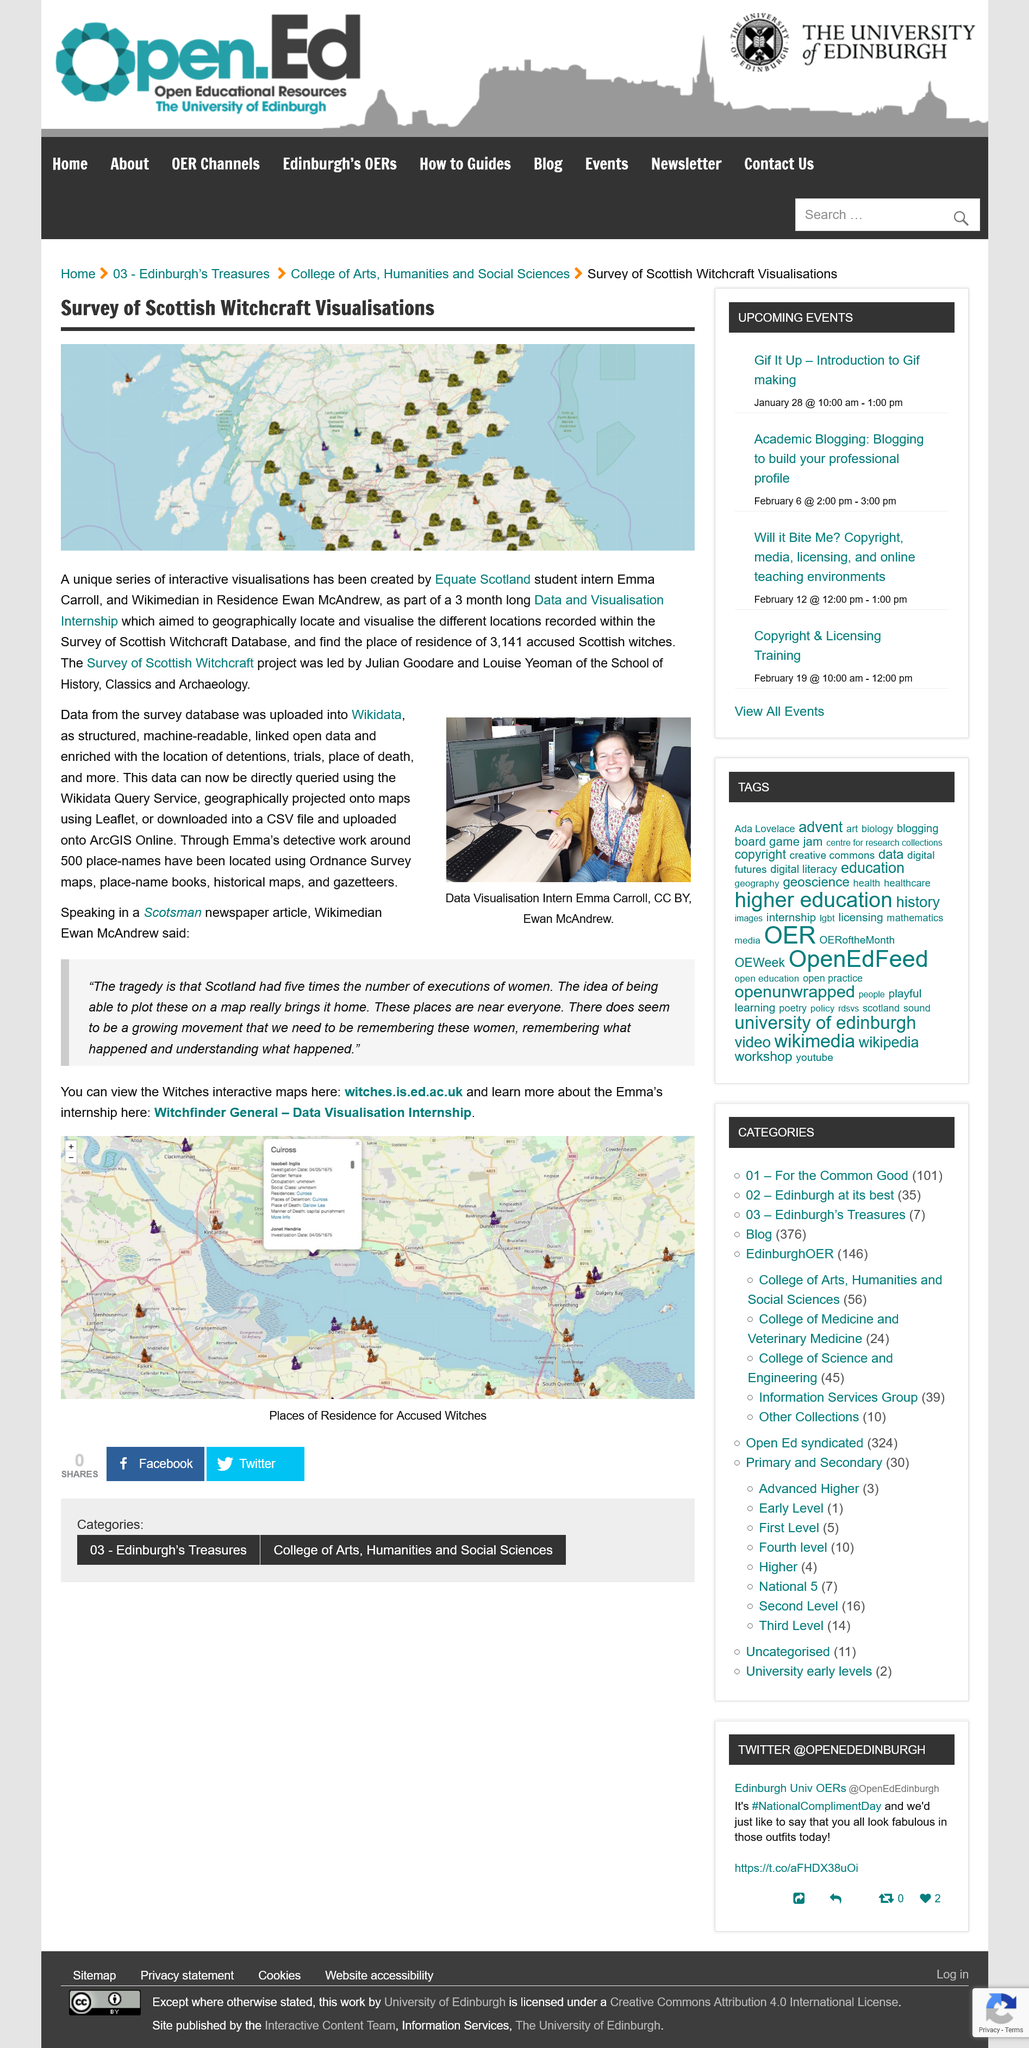Specify some key components in this picture. The survey tracked a total of 3141 accused witches. What is the survey of? Scottish Witchcraft Visualisations. The project was led by Julian Goodare and Louise Yeoman. 